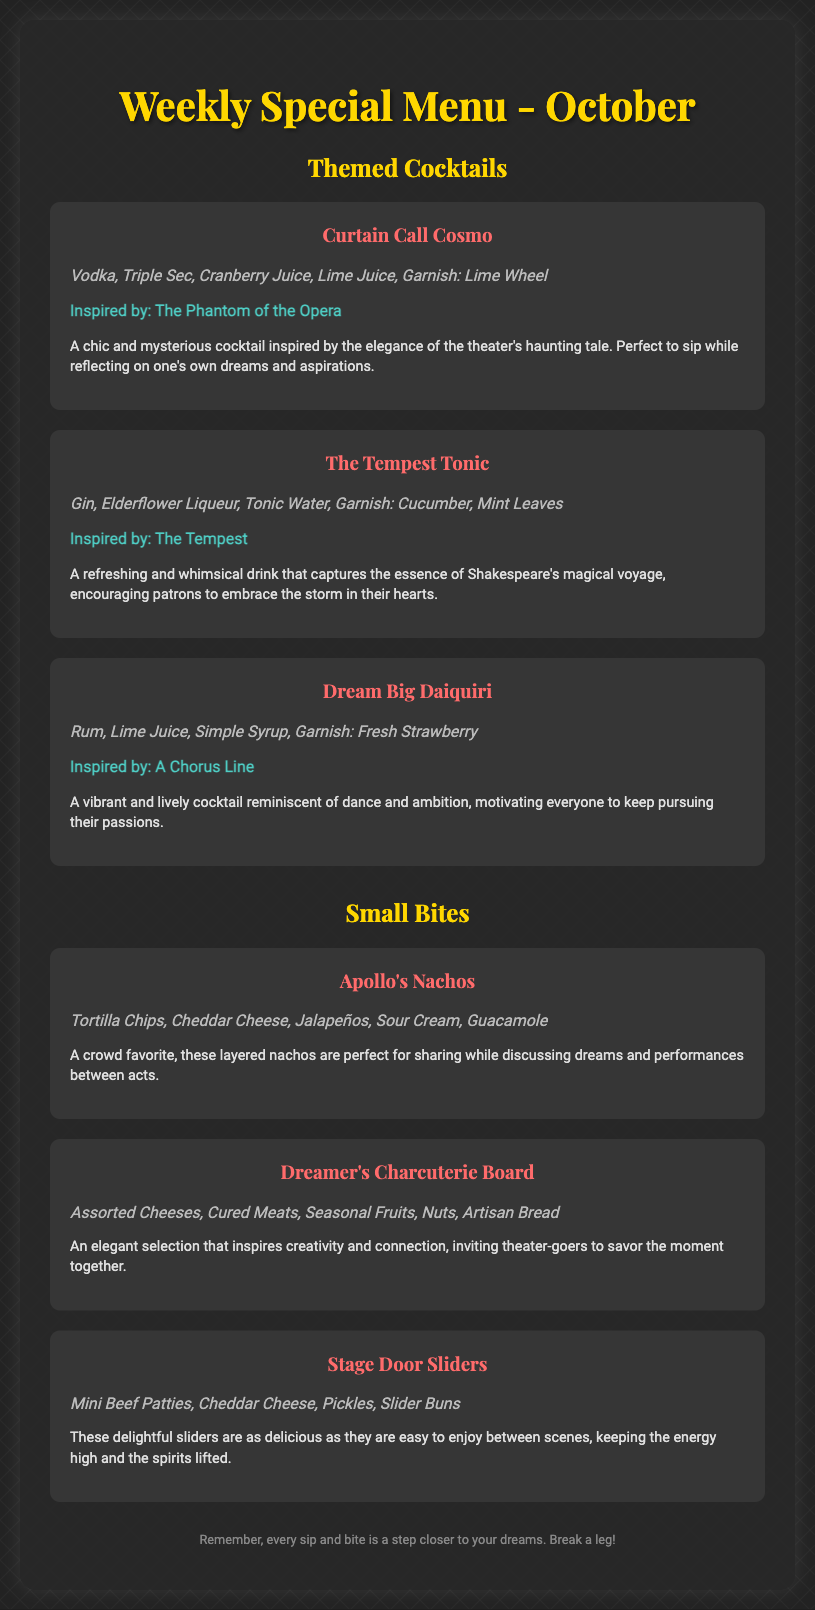What is the title of the menu? The title of the menu is displayed prominently at the top of the document.
Answer: Weekly Special Menu - October How many themed cocktails are listed? The number of themed cocktails can be counted in the menu section under Themed Cocktails.
Answer: Three What is the main ingredient in the Curtain Call Cosmo? The key ingredient for the Curtain Call Cosmo is mentioned at the beginning of its description.
Answer: Vodka Which small bite is inspired by ambition? The description talks about a lively cocktail associated with ambition.
Answer: Dream Big Daiquiri What garnish is used in The Tempest Tonic? The garnish used in The Tempest Tonic is included in the ingredients section.
Answer: Cucumber, Mint Leaves Which cocktail is inspired by The Phantom of the Opera? The name of the cocktail inspired by The Phantom of the Opera is stated directly next to its description.
Answer: Curtain Call Cosmo What type of cheese is included in the Dreamer's Charcuterie Board? The specific ingredients of Dreamer's Charcuterie Board include various types of cheese.
Answer: Assorted Cheeses What is the description theme of the menu? The overall theme is drawn from theater performances and aspirations, reflected particularly in the descriptions.
Answer: Dreams What are Stage Door Sliders primarily made of? The main ingredients of Stage Door Sliders are outlined in the ingredients section.
Answer: Mini Beef Patties, Cheddar Cheese, Pickles, Slider Buns 